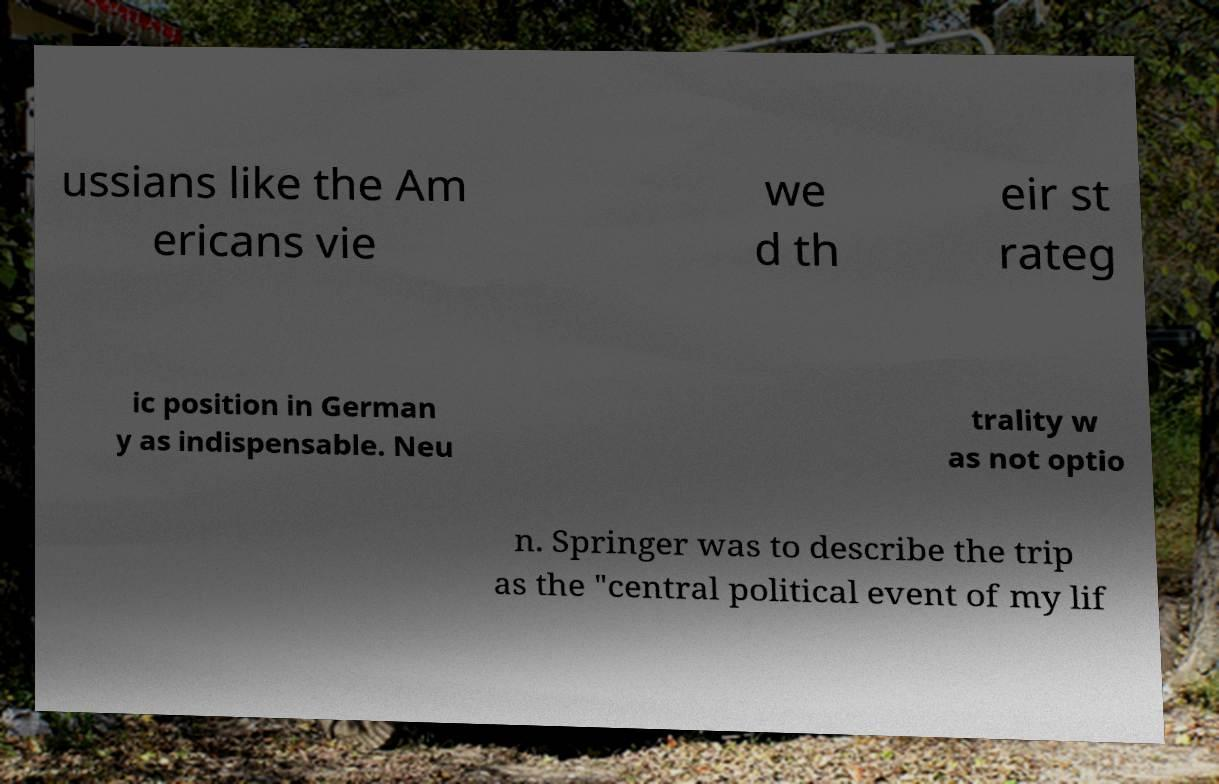Can you accurately transcribe the text from the provided image for me? ussians like the Am ericans vie we d th eir st rateg ic position in German y as indispensable. Neu trality w as not optio n. Springer was to describe the trip as the "central political event of my lif 